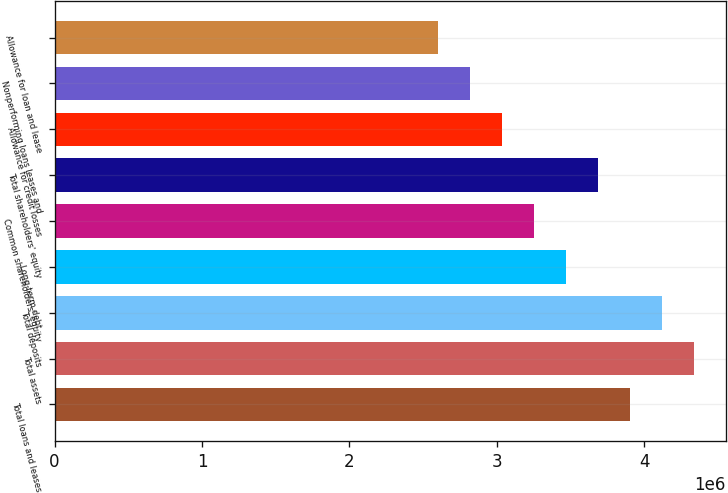Convert chart to OTSL. <chart><loc_0><loc_0><loc_500><loc_500><bar_chart><fcel>Total loans and leases<fcel>Total assets<fcel>Total deposits<fcel>Long-term debt<fcel>Common shareholders' equity<fcel>Total shareholders' equity<fcel>Allowance for credit losses<fcel>Nonperforming loans leases and<fcel>Allowance for loan and lease<nl><fcel>3.90407e+06<fcel>4.33786e+06<fcel>4.12097e+06<fcel>3.47029e+06<fcel>3.25339e+06<fcel>3.68718e+06<fcel>3.0365e+06<fcel>2.81961e+06<fcel>2.60272e+06<nl></chart> 